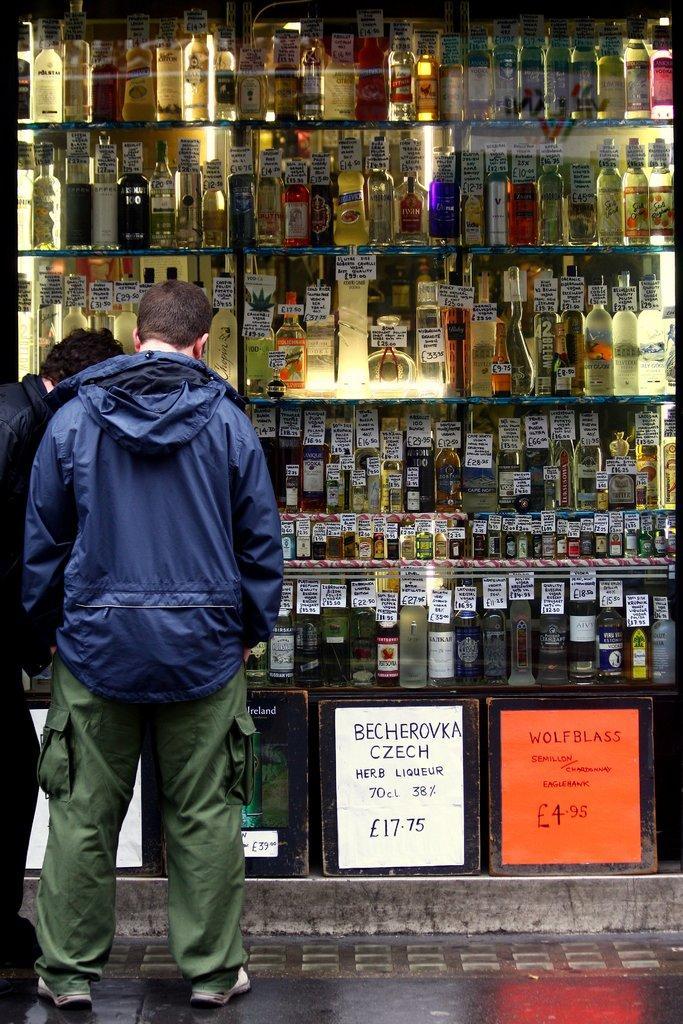Could you give a brief overview of what you see in this image? In this picture I can see two men are standing. Here I can see bottles and boards on which something written on it. This person is wearing a jacket, pant and shoes. 